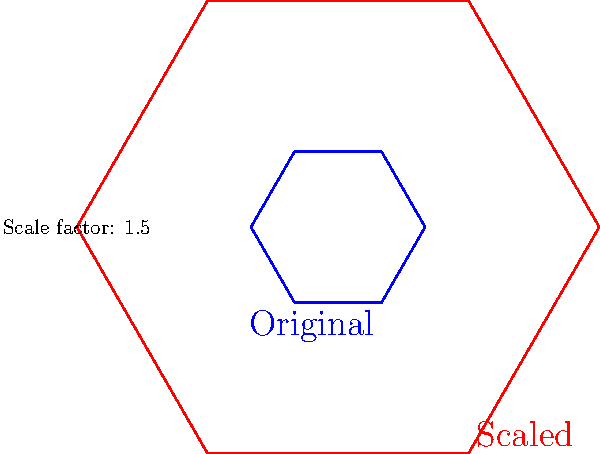As a retired dentist planning to move into a retirement community, you're reviewing floor plans. The retirement home offers to scale up their standard hexagonal-shaped floor plan by a factor of 1.5 to create a more spacious unit. If the original floor plan has an area of 120 square meters, what will be the area of the scaled-up floor plan? Let's approach this step-by-step:

1) In transformational geometry, when we scale a shape, its area changes by the square of the scale factor.

2) The scale factor given is 1.5.

3) To find the area of the scaled shape, we use the formula:
   $${A_{new} = (scale factor)^2 \times A_{original}}$$

4) Substituting our values:
   $${A_{new} = (1.5)^2 \times 120}$$

5) First, calculate $(1.5)^2$:
   $${(1.5)^2 = 2.25}$$

6) Now, multiply by the original area:
   $${A_{new} = 2.25 \times 120 = 270}$$

Therefore, the area of the scaled-up floor plan will be 270 square meters.
Answer: 270 square meters 